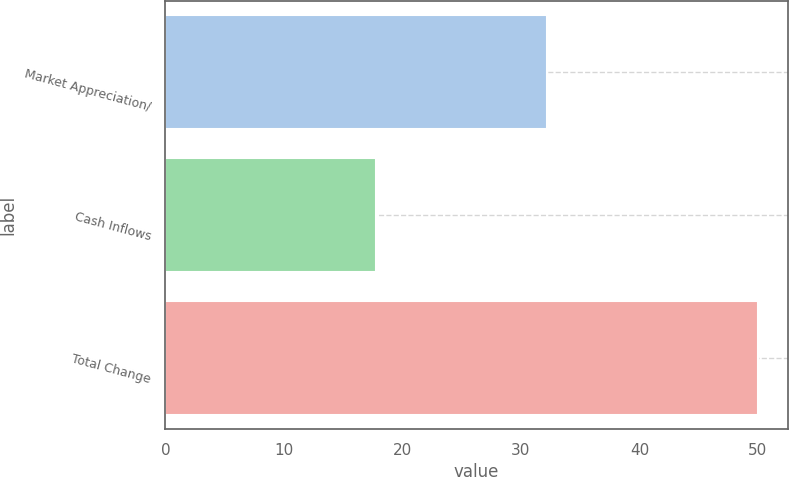<chart> <loc_0><loc_0><loc_500><loc_500><bar_chart><fcel>Market Appreciation/<fcel>Cash Inflows<fcel>Total Change<nl><fcel>32.2<fcel>17.8<fcel>50<nl></chart> 